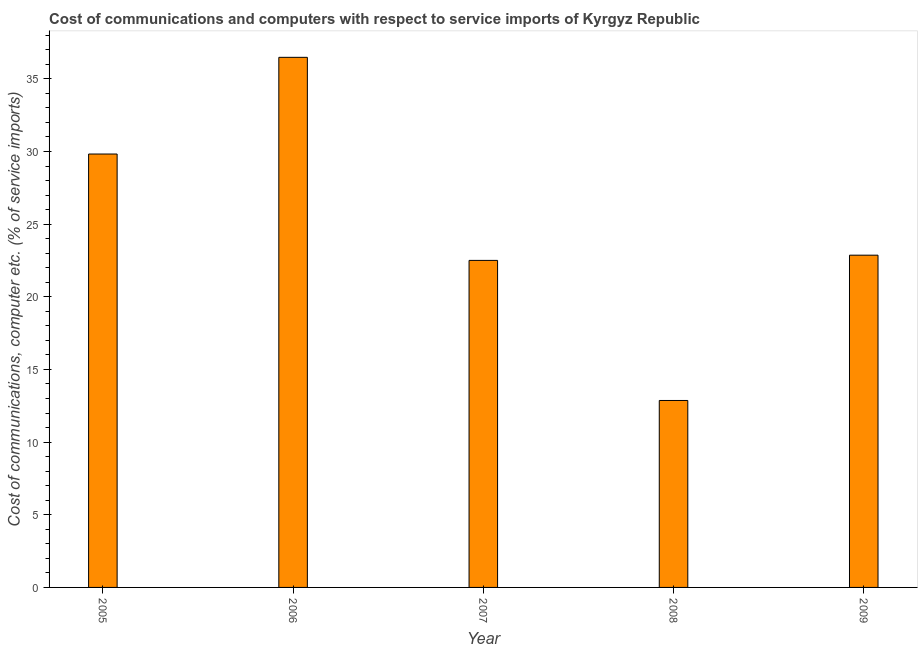Does the graph contain any zero values?
Make the answer very short. No. Does the graph contain grids?
Ensure brevity in your answer.  No. What is the title of the graph?
Make the answer very short. Cost of communications and computers with respect to service imports of Kyrgyz Republic. What is the label or title of the Y-axis?
Your response must be concise. Cost of communications, computer etc. (% of service imports). What is the cost of communications and computer in 2008?
Ensure brevity in your answer.  12.87. Across all years, what is the maximum cost of communications and computer?
Offer a very short reply. 36.48. Across all years, what is the minimum cost of communications and computer?
Offer a terse response. 12.87. In which year was the cost of communications and computer minimum?
Provide a succinct answer. 2008. What is the sum of the cost of communications and computer?
Give a very brief answer. 124.54. What is the difference between the cost of communications and computer in 2005 and 2007?
Provide a short and direct response. 7.32. What is the average cost of communications and computer per year?
Offer a very short reply. 24.91. What is the median cost of communications and computer?
Provide a short and direct response. 22.86. In how many years, is the cost of communications and computer greater than 32 %?
Ensure brevity in your answer.  1. What is the ratio of the cost of communications and computer in 2006 to that in 2007?
Your answer should be very brief. 1.62. Is the difference between the cost of communications and computer in 2005 and 2009 greater than the difference between any two years?
Give a very brief answer. No. What is the difference between the highest and the second highest cost of communications and computer?
Your answer should be compact. 6.65. What is the difference between the highest and the lowest cost of communications and computer?
Keep it short and to the point. 23.61. How many bars are there?
Your answer should be compact. 5. How many years are there in the graph?
Your response must be concise. 5. What is the difference between two consecutive major ticks on the Y-axis?
Ensure brevity in your answer.  5. Are the values on the major ticks of Y-axis written in scientific E-notation?
Provide a short and direct response. No. What is the Cost of communications, computer etc. (% of service imports) in 2005?
Provide a short and direct response. 29.83. What is the Cost of communications, computer etc. (% of service imports) of 2006?
Offer a very short reply. 36.48. What is the Cost of communications, computer etc. (% of service imports) of 2007?
Offer a very short reply. 22.51. What is the Cost of communications, computer etc. (% of service imports) in 2008?
Your answer should be very brief. 12.87. What is the Cost of communications, computer etc. (% of service imports) of 2009?
Your answer should be compact. 22.86. What is the difference between the Cost of communications, computer etc. (% of service imports) in 2005 and 2006?
Offer a terse response. -6.65. What is the difference between the Cost of communications, computer etc. (% of service imports) in 2005 and 2007?
Your response must be concise. 7.32. What is the difference between the Cost of communications, computer etc. (% of service imports) in 2005 and 2008?
Your response must be concise. 16.96. What is the difference between the Cost of communications, computer etc. (% of service imports) in 2005 and 2009?
Keep it short and to the point. 6.96. What is the difference between the Cost of communications, computer etc. (% of service imports) in 2006 and 2007?
Ensure brevity in your answer.  13.97. What is the difference between the Cost of communications, computer etc. (% of service imports) in 2006 and 2008?
Offer a terse response. 23.61. What is the difference between the Cost of communications, computer etc. (% of service imports) in 2006 and 2009?
Give a very brief answer. 13.62. What is the difference between the Cost of communications, computer etc. (% of service imports) in 2007 and 2008?
Ensure brevity in your answer.  9.64. What is the difference between the Cost of communications, computer etc. (% of service imports) in 2007 and 2009?
Offer a very short reply. -0.36. What is the difference between the Cost of communications, computer etc. (% of service imports) in 2008 and 2009?
Your answer should be very brief. -10. What is the ratio of the Cost of communications, computer etc. (% of service imports) in 2005 to that in 2006?
Give a very brief answer. 0.82. What is the ratio of the Cost of communications, computer etc. (% of service imports) in 2005 to that in 2007?
Provide a succinct answer. 1.32. What is the ratio of the Cost of communications, computer etc. (% of service imports) in 2005 to that in 2008?
Keep it short and to the point. 2.32. What is the ratio of the Cost of communications, computer etc. (% of service imports) in 2005 to that in 2009?
Offer a terse response. 1.3. What is the ratio of the Cost of communications, computer etc. (% of service imports) in 2006 to that in 2007?
Your answer should be very brief. 1.62. What is the ratio of the Cost of communications, computer etc. (% of service imports) in 2006 to that in 2008?
Offer a very short reply. 2.84. What is the ratio of the Cost of communications, computer etc. (% of service imports) in 2006 to that in 2009?
Offer a very short reply. 1.59. What is the ratio of the Cost of communications, computer etc. (% of service imports) in 2007 to that in 2008?
Ensure brevity in your answer.  1.75. What is the ratio of the Cost of communications, computer etc. (% of service imports) in 2008 to that in 2009?
Give a very brief answer. 0.56. 